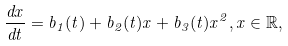<formula> <loc_0><loc_0><loc_500><loc_500>\frac { d x } { d t } = b _ { 1 } ( t ) + b _ { 2 } ( t ) x + b _ { 3 } ( t ) x ^ { 2 } , x \in \mathbb { R } ,</formula> 